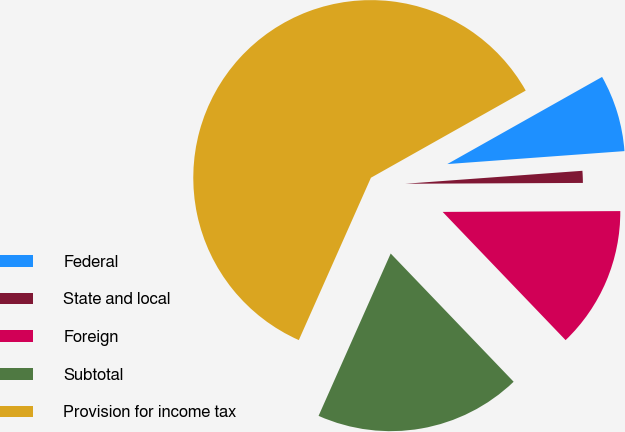Convert chart. <chart><loc_0><loc_0><loc_500><loc_500><pie_chart><fcel>Federal<fcel>State and local<fcel>Foreign<fcel>Subtotal<fcel>Provision for income tax<nl><fcel>7.0%<fcel>1.09%<fcel>12.91%<fcel>18.82%<fcel>60.19%<nl></chart> 